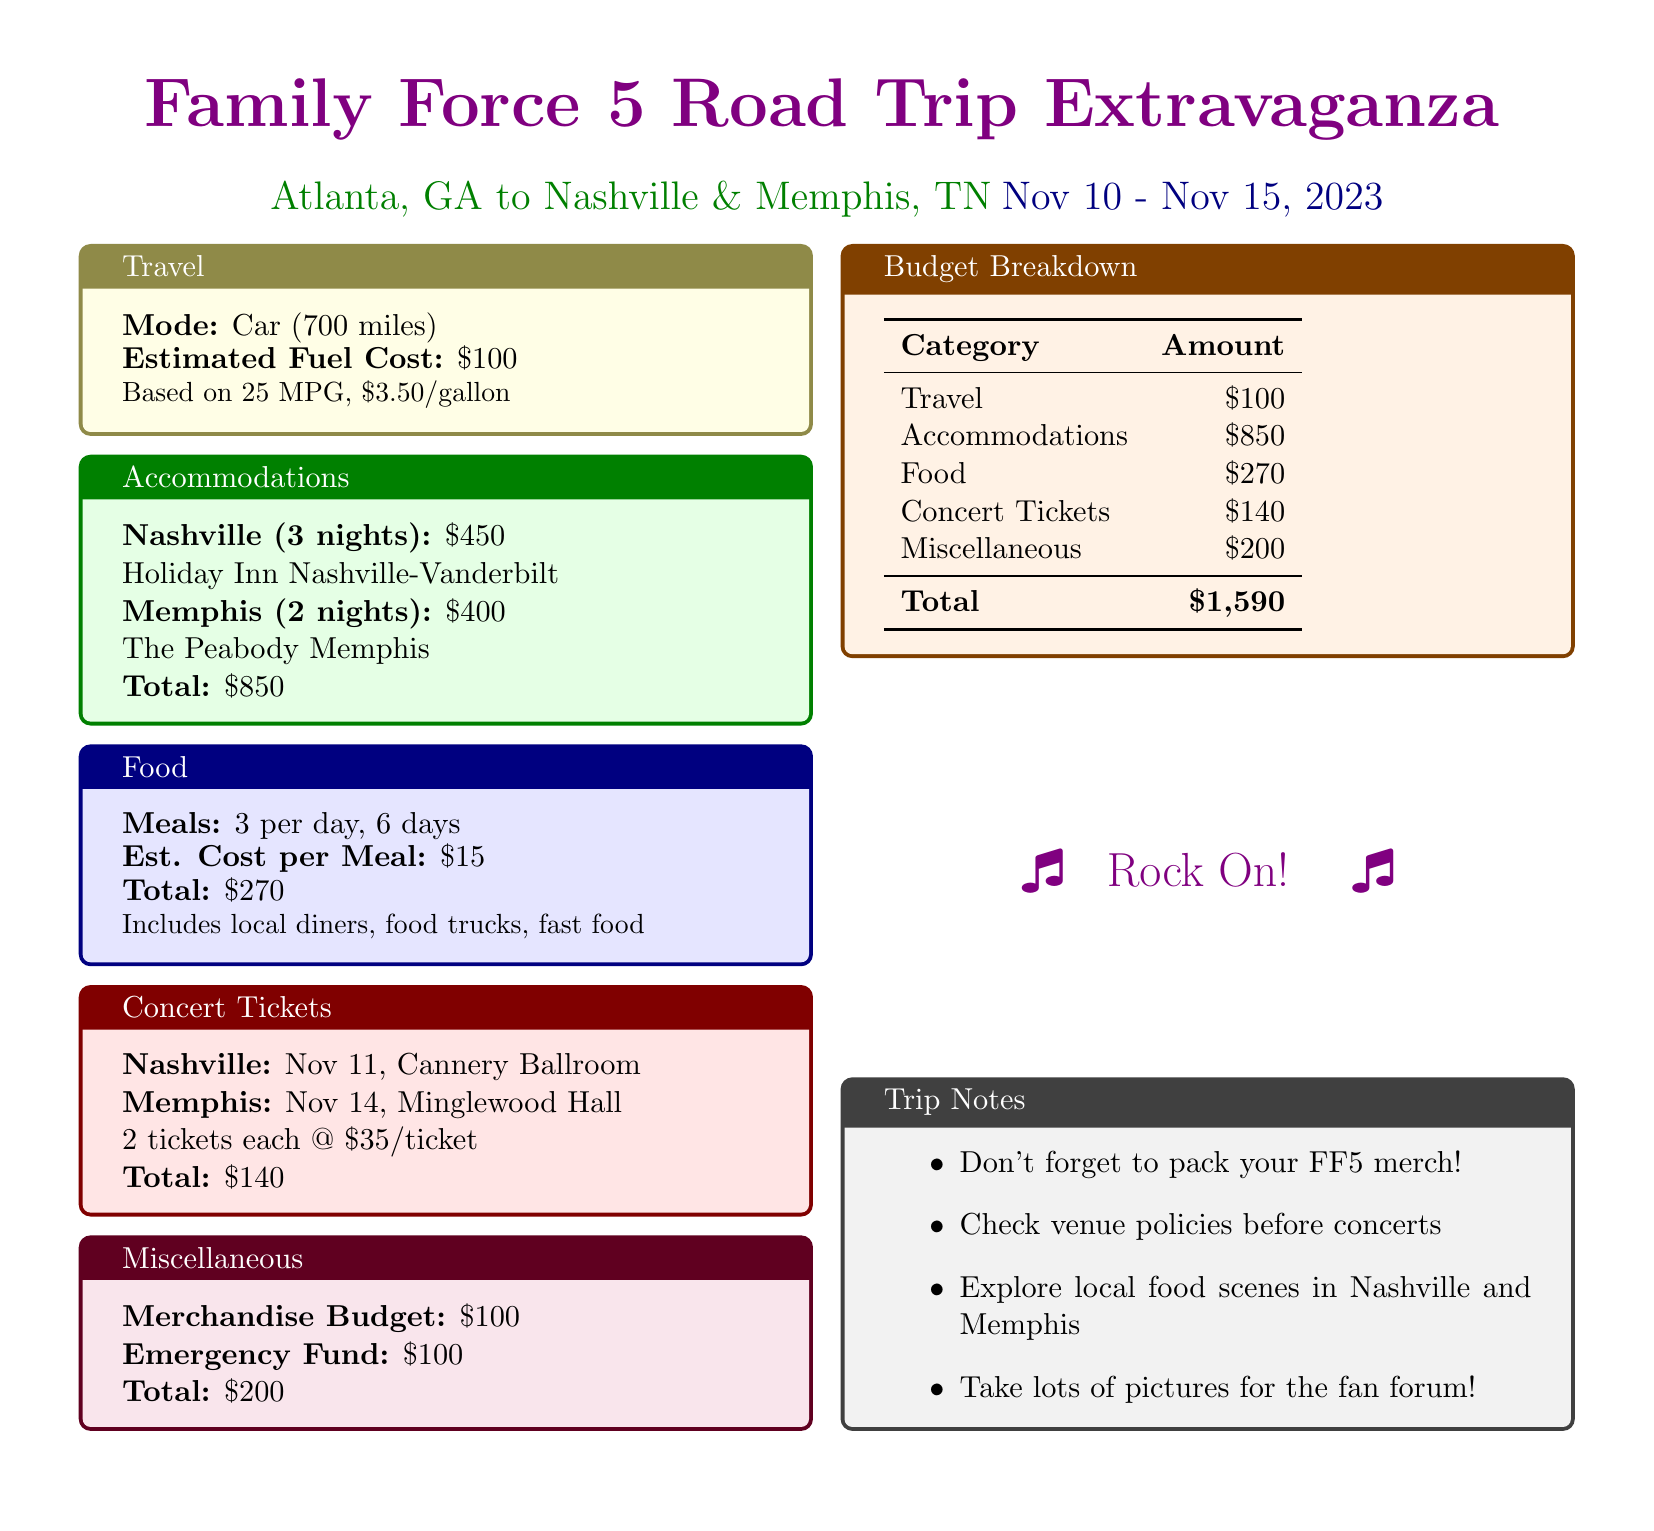What are the travel expenses? Travel expenses are listed under the Travel section and total $100.
Answer: $100 How many nights will be spent in Nashville? The Nashville accommodations section states that there will be 3 nights spent in Nashville.
Answer: 3 nights What is the estimated cost of food for the trip? The food total is specifically mentioned as $270, calculated based on daily meals.
Answer: $270 What is the total accommodation cost? The total accommodation cost is listed in the Accommodations section, combining both Nashville and Memphis.
Answer: $850 How many concert tickets are purchased for each concert? The concert tickets section specifies that 2 tickets were purchased for each concert.
Answer: 2 tickets What is the budget for merchandise? The Miscellaneous section provides a specific merchandise budget amount.
Answer: $100 What type of vehicle is used for travel? The Travel section mentions that a car is being used for the trip.
Answer: Car What are the total estimated costs for the entire trip? The Budget Breakdown section concludes with a total cost calculation for the trip.
Answer: $1,590 How many days does the trip last? The dates provided indicate the trip lasts from November 10 to November 15.
Answer: 6 days 